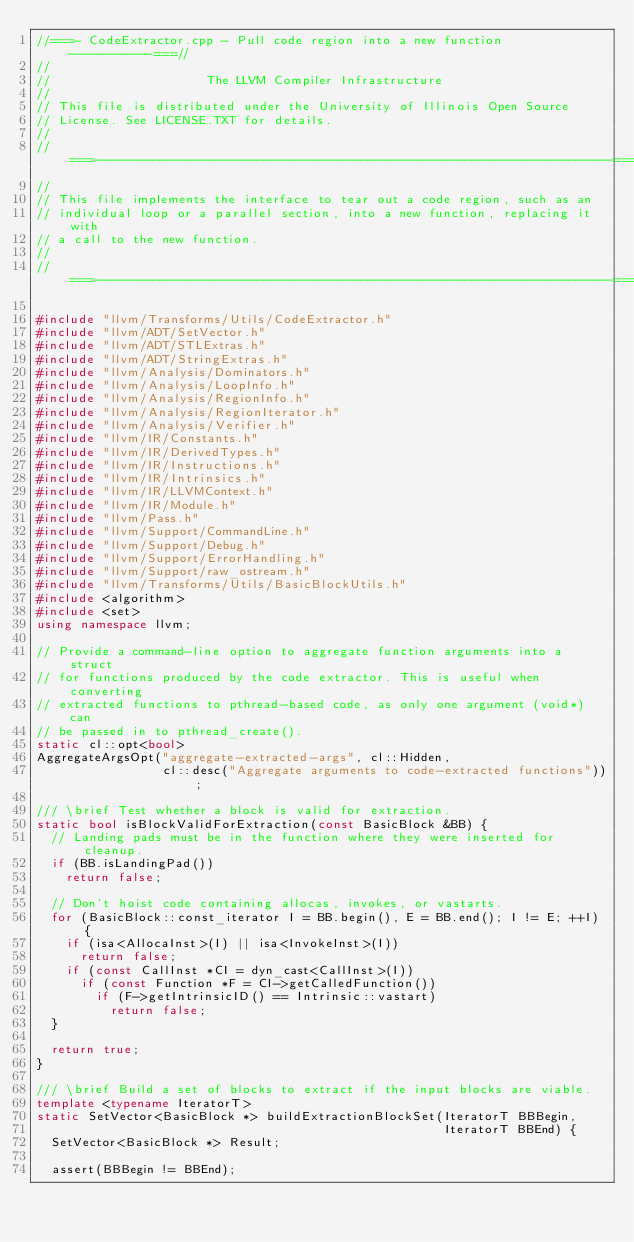<code> <loc_0><loc_0><loc_500><loc_500><_C++_>//===- CodeExtractor.cpp - Pull code region into a new function -----------===//
//
//                     The LLVM Compiler Infrastructure
//
// This file is distributed under the University of Illinois Open Source
// License. See LICENSE.TXT for details.
//
//===----------------------------------------------------------------------===//
//
// This file implements the interface to tear out a code region, such as an
// individual loop or a parallel section, into a new function, replacing it with
// a call to the new function.
//
//===----------------------------------------------------------------------===//

#include "llvm/Transforms/Utils/CodeExtractor.h"
#include "llvm/ADT/SetVector.h"
#include "llvm/ADT/STLExtras.h"
#include "llvm/ADT/StringExtras.h"
#include "llvm/Analysis/Dominators.h"
#include "llvm/Analysis/LoopInfo.h"
#include "llvm/Analysis/RegionInfo.h"
#include "llvm/Analysis/RegionIterator.h"
#include "llvm/Analysis/Verifier.h"
#include "llvm/IR/Constants.h"
#include "llvm/IR/DerivedTypes.h"
#include "llvm/IR/Instructions.h"
#include "llvm/IR/Intrinsics.h"
#include "llvm/IR/LLVMContext.h"
#include "llvm/IR/Module.h"
#include "llvm/Pass.h"
#include "llvm/Support/CommandLine.h"
#include "llvm/Support/Debug.h"
#include "llvm/Support/ErrorHandling.h"
#include "llvm/Support/raw_ostream.h"
#include "llvm/Transforms/Utils/BasicBlockUtils.h"
#include <algorithm>
#include <set>
using namespace llvm;

// Provide a command-line option to aggregate function arguments into a struct
// for functions produced by the code extractor. This is useful when converting
// extracted functions to pthread-based code, as only one argument (void*) can
// be passed in to pthread_create().
static cl::opt<bool>
AggregateArgsOpt("aggregate-extracted-args", cl::Hidden,
                 cl::desc("Aggregate arguments to code-extracted functions"));

/// \brief Test whether a block is valid for extraction.
static bool isBlockValidForExtraction(const BasicBlock &BB) {
  // Landing pads must be in the function where they were inserted for cleanup.
  if (BB.isLandingPad())
    return false;

  // Don't hoist code containing allocas, invokes, or vastarts.
  for (BasicBlock::const_iterator I = BB.begin(), E = BB.end(); I != E; ++I) {
    if (isa<AllocaInst>(I) || isa<InvokeInst>(I))
      return false;
    if (const CallInst *CI = dyn_cast<CallInst>(I))
      if (const Function *F = CI->getCalledFunction())
        if (F->getIntrinsicID() == Intrinsic::vastart)
          return false;
  }

  return true;
}

/// \brief Build a set of blocks to extract if the input blocks are viable.
template <typename IteratorT>
static SetVector<BasicBlock *> buildExtractionBlockSet(IteratorT BBBegin,
                                                       IteratorT BBEnd) {
  SetVector<BasicBlock *> Result;

  assert(BBBegin != BBEnd);
</code> 